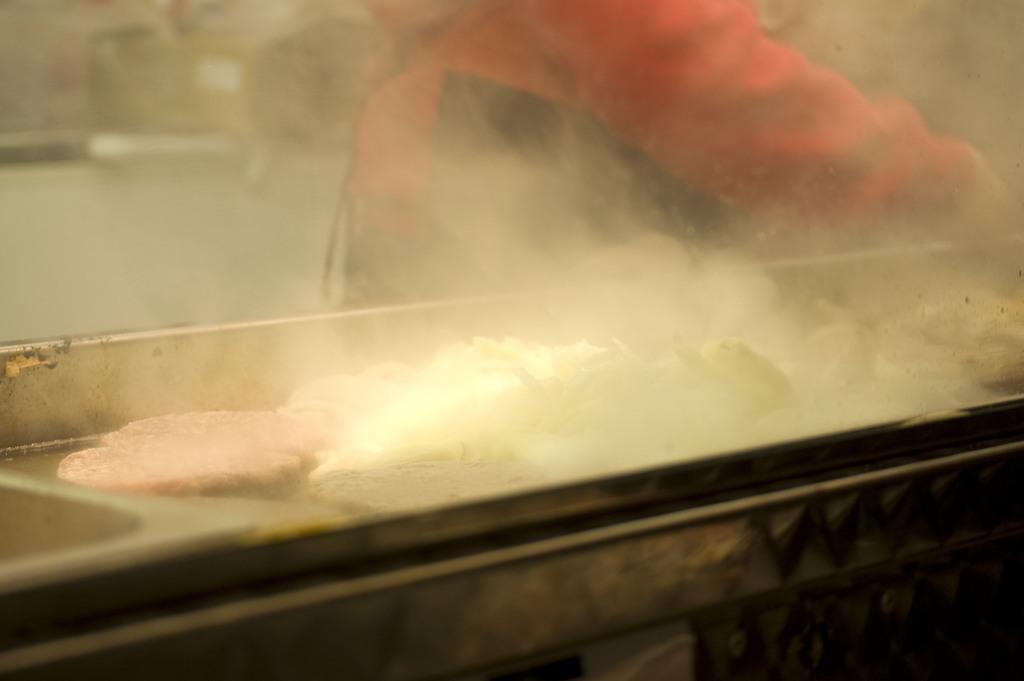Please provide a concise description of this image. In this image there is nothing clear. I think there is a bridge. There may be a person. There is full smoke. 